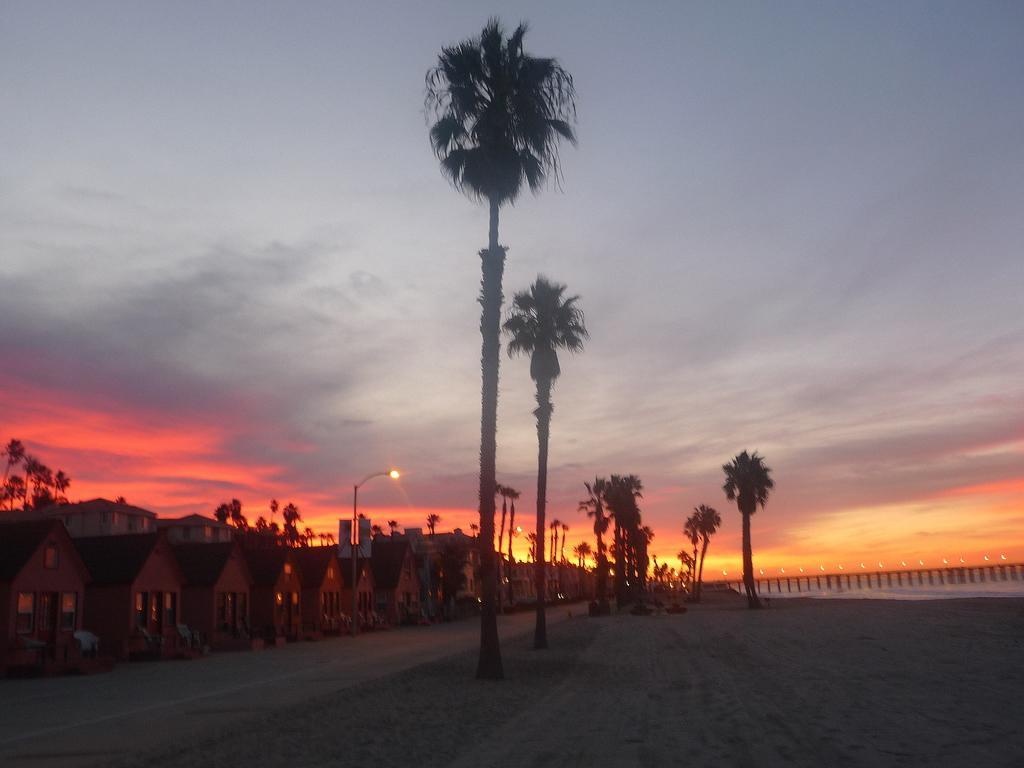Please provide a concise description of this image. In this image, I can see the trees and small houses. At the bottom of the image, I can see the pathway. In the background, there is the sky. On the right side of the image, It looks like a bridge. 